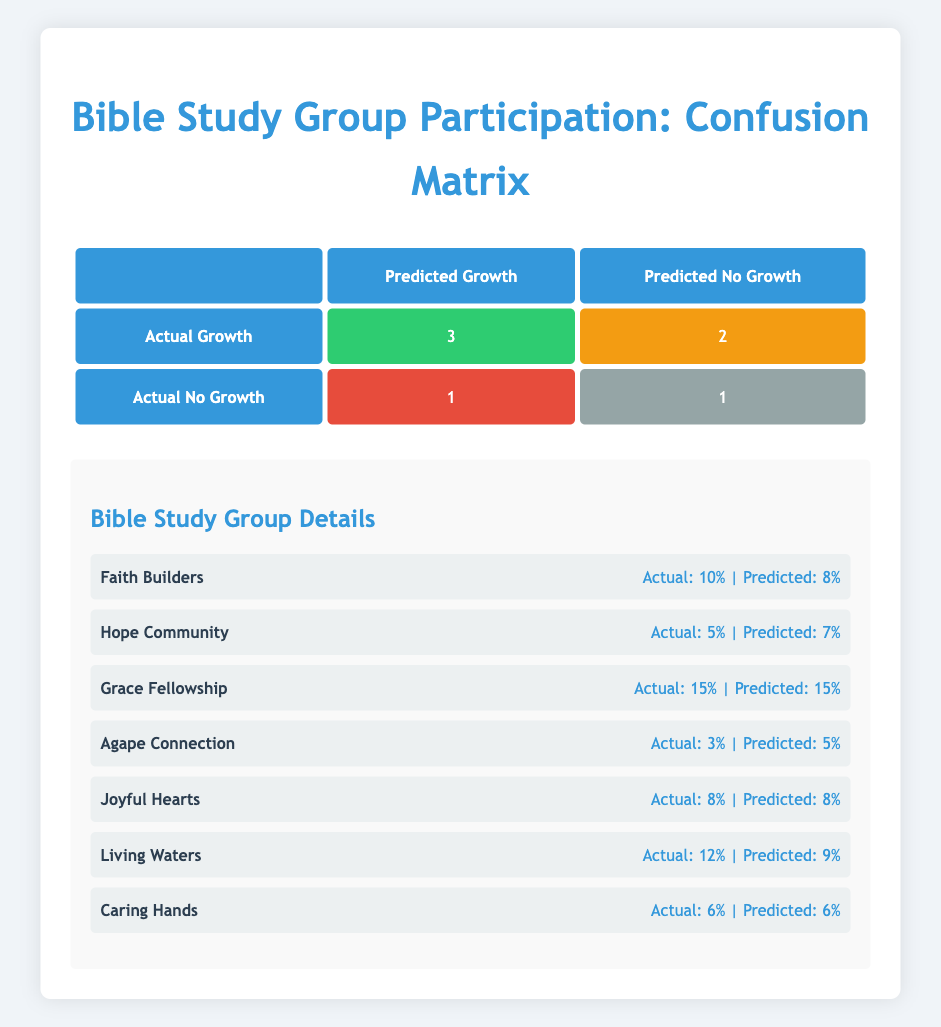What is the actual growth rate for the "Joyful Hearts" group? The actual growth rate for the "Joyful Hearts" group can be found in the table under the "Actual Growth" column. It shows that the actual growth rate is 8%.
Answer: 8% How many groups had true positive predictions? To determine the number of true positive predictions, we look at the participation status in the table, specifically the "True Positive" count, which is explicitly mentioned as 3.
Answer: 3 What is the difference between the predicted and actual growth rates for "Living Waters"? For the "Living Waters" group, the actual growth rate is 12% and the predicted growth rate is 9%. The difference is calculated as 12% - 9% = 3%.
Answer: 3% Did "Grace Fellowship" have a false negative prediction? By checking the participation status of "Grace Fellowship," which is noted as "True Positive," it indicates that there was no false negative prediction for this group.
Answer: No What is the average actual growth rate of all groups with true positive predictions? The actual growth rates for true positive predictions are: 10% (Faith Builders), 15% (Grace Fellowship), 8% (Joyful Hearts), and 6% (Caring Hands). The sum is 10 + 15 + 8 + 6 = 39%. There are 4 groups, so the average is 39% / 4 = 9.75%.
Answer: 9.75% How many groups had a predicted growth rate greater than their actual growth rate? There are two groups that had a predicted growth rate greater than their actual growth rate: "Hope Community" (predicted 7%, actual 5%) and "Agape Connection" (predicted 5%, actual 3%). Therefore, there are 2 groups.
Answer: 2 What percentage of groups had a predicted growth rate that was equal to the actual growth rate? To find this percentage, we count the groups where the predicted growth rate equals the actual growth rate. The groups are: "Faith Builders," "Grace Fellowship," "Joyful Hearts," and "Caring Hands," totaling 4 groups. The overall total of groups is 7, so the percentage is (4/7) * 100 = 57.14%.
Answer: 57.14% What is the count of groups that were classified as false positive? Checking the data, there is one group classified as false positive, which is "Living Waters." Thus, the count is 1.
Answer: 1 How many groups had actual growth rates below 6%? In the table, only "Agape Connection" has an actual growth rate of 3%, which is below 6%. Therefore, the count of groups is 1.
Answer: 1 